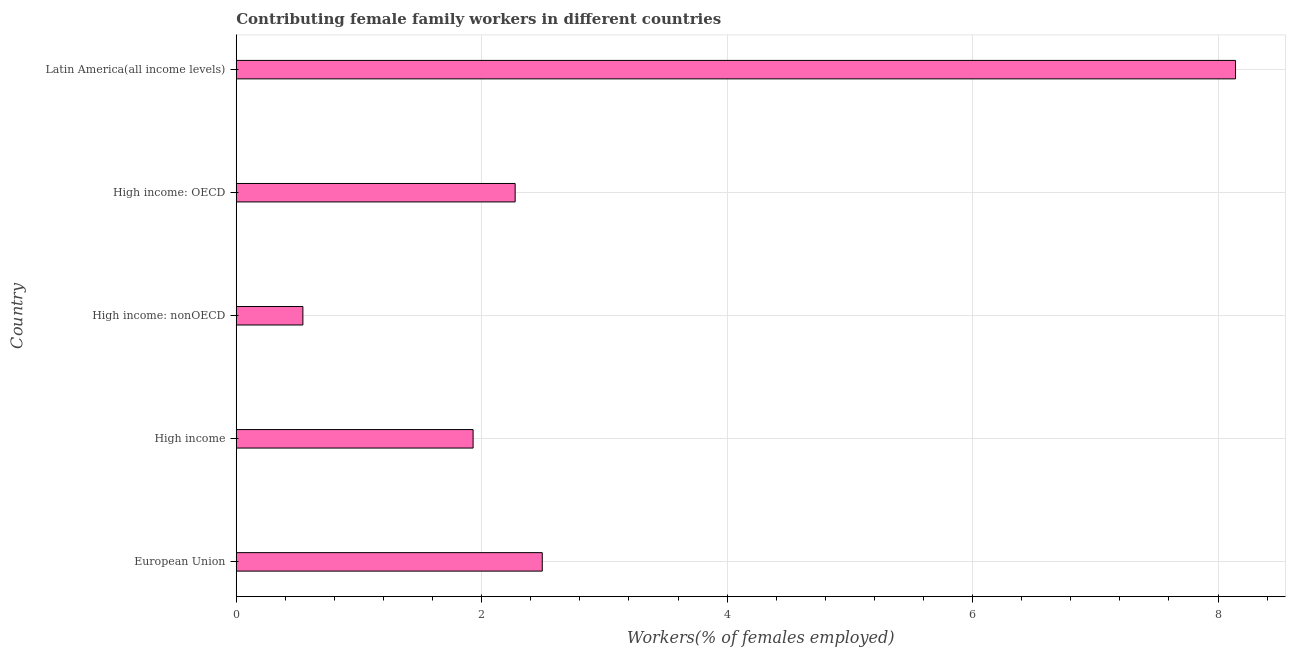What is the title of the graph?
Give a very brief answer. Contributing female family workers in different countries. What is the label or title of the X-axis?
Give a very brief answer. Workers(% of females employed). What is the contributing female family workers in European Union?
Ensure brevity in your answer.  2.49. Across all countries, what is the maximum contributing female family workers?
Ensure brevity in your answer.  8.14. Across all countries, what is the minimum contributing female family workers?
Keep it short and to the point. 0.54. In which country was the contributing female family workers maximum?
Your response must be concise. Latin America(all income levels). In which country was the contributing female family workers minimum?
Provide a short and direct response. High income: nonOECD. What is the sum of the contributing female family workers?
Ensure brevity in your answer.  15.38. What is the difference between the contributing female family workers in High income and Latin America(all income levels)?
Keep it short and to the point. -6.21. What is the average contributing female family workers per country?
Provide a succinct answer. 3.08. What is the median contributing female family workers?
Offer a terse response. 2.27. What is the ratio of the contributing female family workers in High income: nonOECD to that in Latin America(all income levels)?
Keep it short and to the point. 0.07. Is the difference between the contributing female family workers in High income: OECD and Latin America(all income levels) greater than the difference between any two countries?
Offer a terse response. No. What is the difference between the highest and the second highest contributing female family workers?
Your answer should be very brief. 5.65. Is the sum of the contributing female family workers in European Union and High income: OECD greater than the maximum contributing female family workers across all countries?
Offer a terse response. No. In how many countries, is the contributing female family workers greater than the average contributing female family workers taken over all countries?
Ensure brevity in your answer.  1. How many bars are there?
Offer a very short reply. 5. Are the values on the major ticks of X-axis written in scientific E-notation?
Offer a very short reply. No. What is the Workers(% of females employed) of European Union?
Provide a succinct answer. 2.49. What is the Workers(% of females employed) in High income?
Your answer should be very brief. 1.93. What is the Workers(% of females employed) in High income: nonOECD?
Give a very brief answer. 0.54. What is the Workers(% of females employed) in High income: OECD?
Make the answer very short. 2.27. What is the Workers(% of females employed) in Latin America(all income levels)?
Your answer should be very brief. 8.14. What is the difference between the Workers(% of females employed) in European Union and High income?
Offer a very short reply. 0.56. What is the difference between the Workers(% of females employed) in European Union and High income: nonOECD?
Give a very brief answer. 1.95. What is the difference between the Workers(% of females employed) in European Union and High income: OECD?
Your answer should be very brief. 0.22. What is the difference between the Workers(% of females employed) in European Union and Latin America(all income levels)?
Offer a very short reply. -5.65. What is the difference between the Workers(% of females employed) in High income and High income: nonOECD?
Give a very brief answer. 1.39. What is the difference between the Workers(% of females employed) in High income and High income: OECD?
Give a very brief answer. -0.34. What is the difference between the Workers(% of females employed) in High income and Latin America(all income levels)?
Provide a succinct answer. -6.21. What is the difference between the Workers(% of females employed) in High income: nonOECD and High income: OECD?
Offer a terse response. -1.73. What is the difference between the Workers(% of females employed) in High income: nonOECD and Latin America(all income levels)?
Ensure brevity in your answer.  -7.6. What is the difference between the Workers(% of females employed) in High income: OECD and Latin America(all income levels)?
Your answer should be compact. -5.87. What is the ratio of the Workers(% of females employed) in European Union to that in High income?
Provide a succinct answer. 1.29. What is the ratio of the Workers(% of females employed) in European Union to that in High income: nonOECD?
Offer a terse response. 4.59. What is the ratio of the Workers(% of females employed) in European Union to that in High income: OECD?
Your answer should be compact. 1.1. What is the ratio of the Workers(% of females employed) in European Union to that in Latin America(all income levels)?
Ensure brevity in your answer.  0.31. What is the ratio of the Workers(% of females employed) in High income to that in High income: nonOECD?
Keep it short and to the point. 3.55. What is the ratio of the Workers(% of females employed) in High income to that in High income: OECD?
Ensure brevity in your answer.  0.85. What is the ratio of the Workers(% of females employed) in High income to that in Latin America(all income levels)?
Provide a succinct answer. 0.24. What is the ratio of the Workers(% of females employed) in High income: nonOECD to that in High income: OECD?
Offer a very short reply. 0.24. What is the ratio of the Workers(% of females employed) in High income: nonOECD to that in Latin America(all income levels)?
Your answer should be very brief. 0.07. What is the ratio of the Workers(% of females employed) in High income: OECD to that in Latin America(all income levels)?
Offer a terse response. 0.28. 